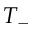<formula> <loc_0><loc_0><loc_500><loc_500>T _ { - }</formula> 